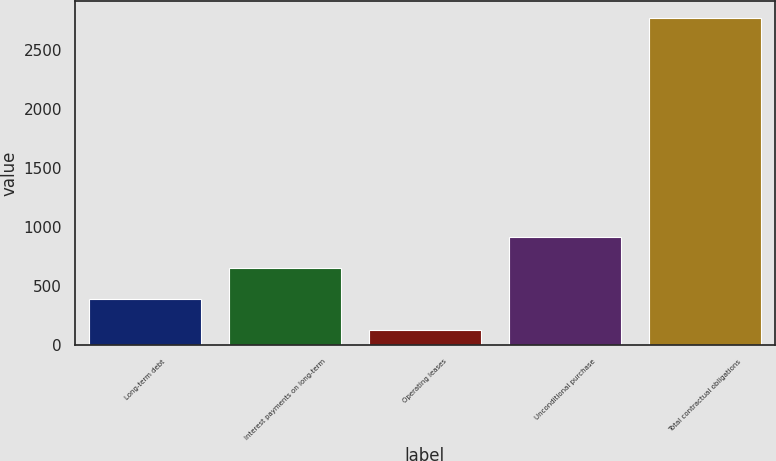<chart> <loc_0><loc_0><loc_500><loc_500><bar_chart><fcel>Long-term debt<fcel>Interest payments on long-term<fcel>Operating leases<fcel>Unconditional purchase<fcel>Total contractual obligations<nl><fcel>390.5<fcel>655<fcel>126<fcel>919.5<fcel>2771<nl></chart> 